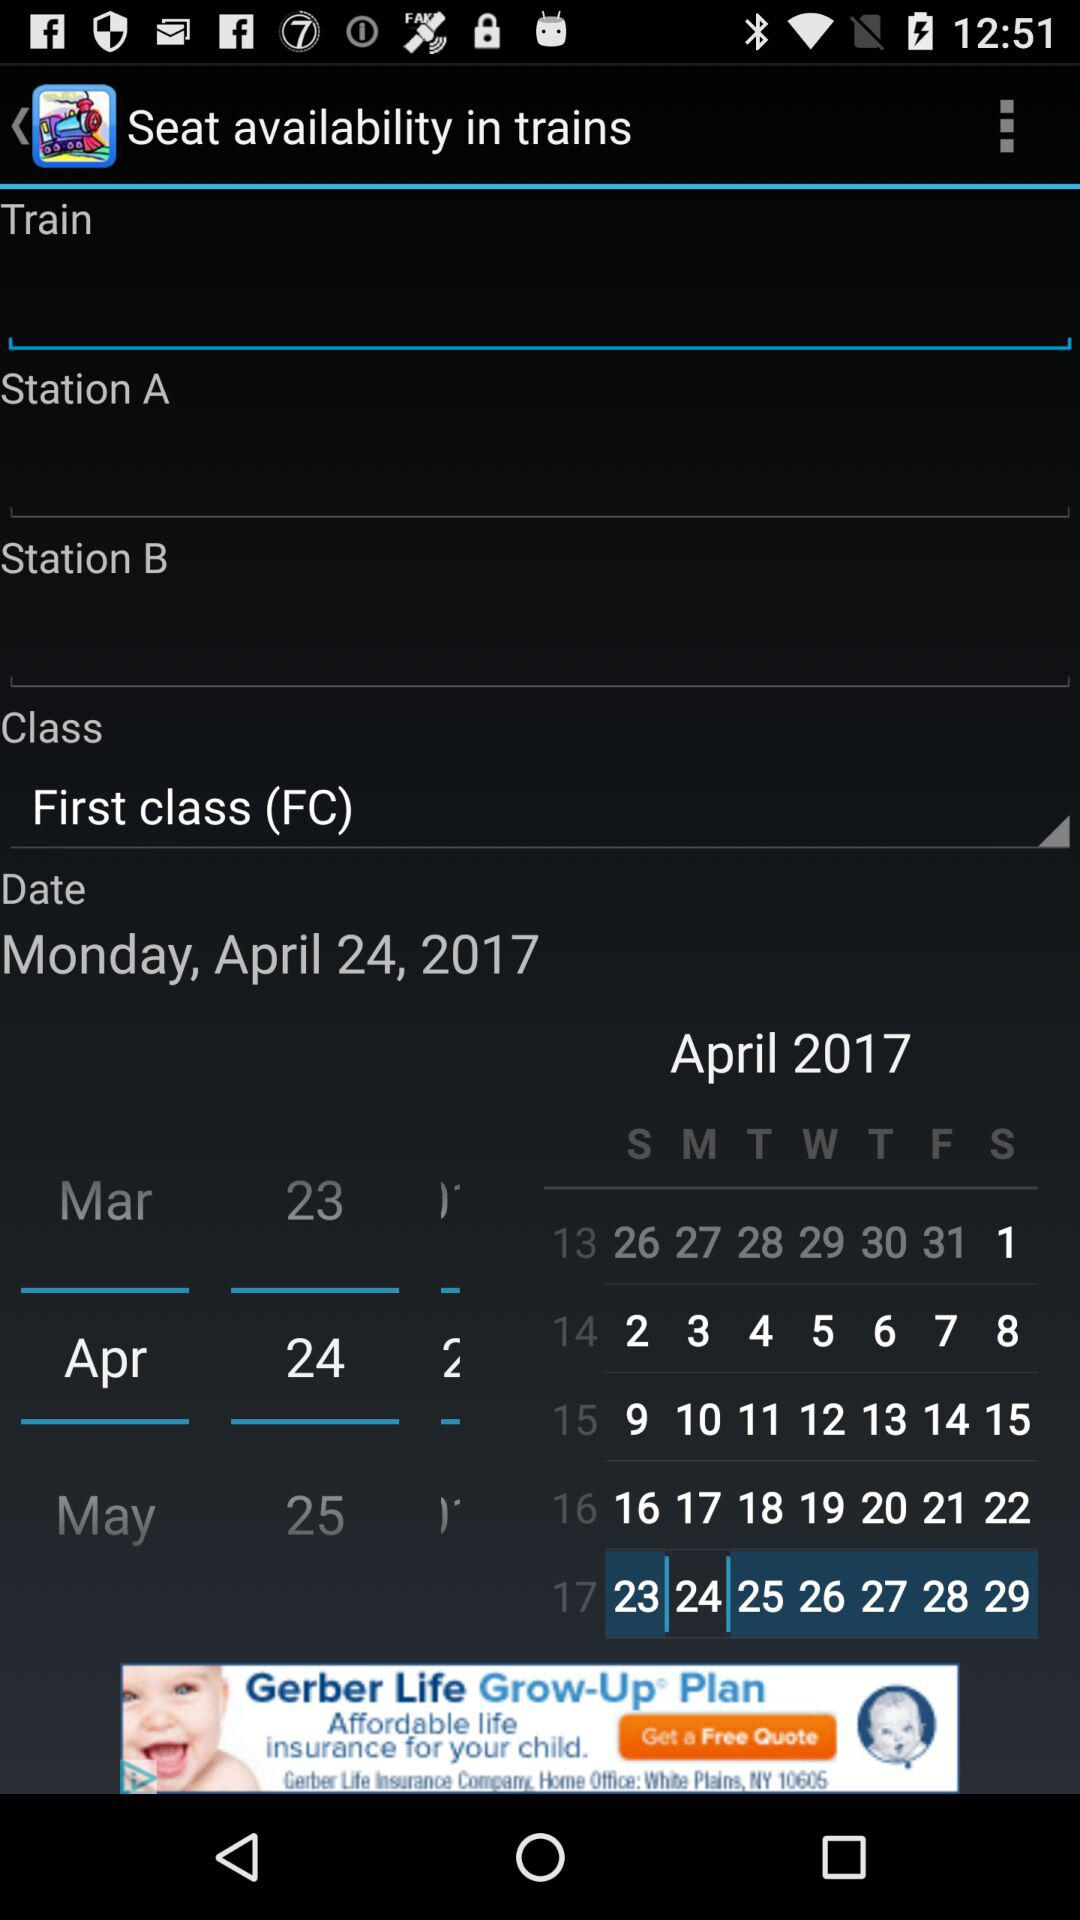Which "Class" is selected? The selected "Class" is "First class (FC)". 